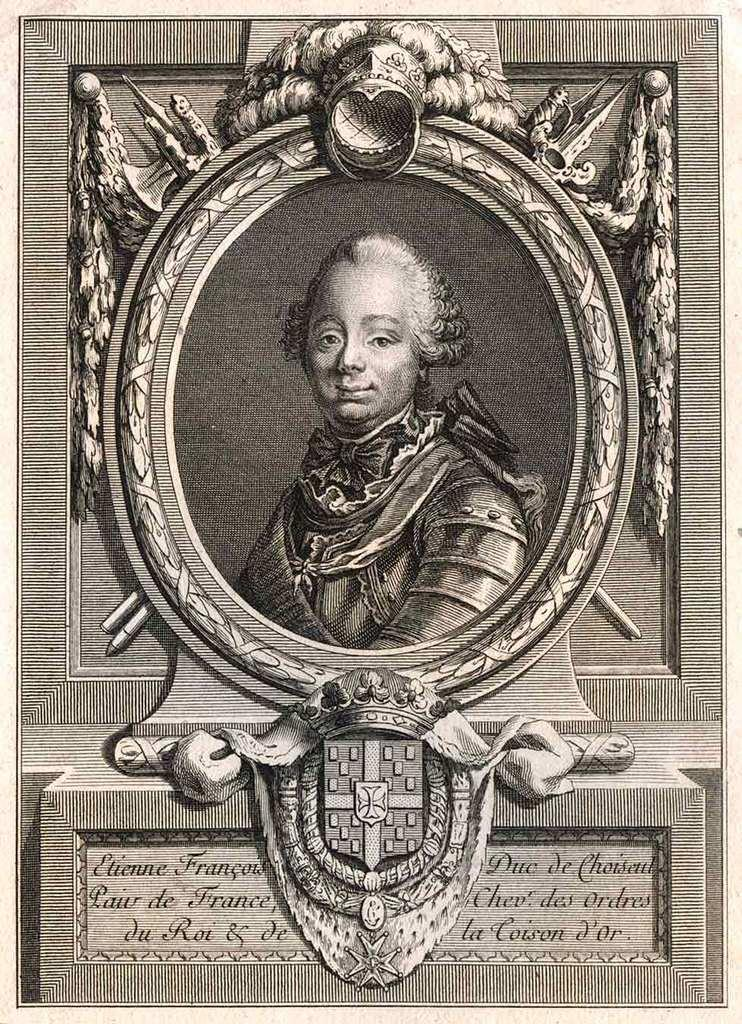<image>
Summarize the visual content of the image. An artist's drawing of a portrait of Etienne Francois. 